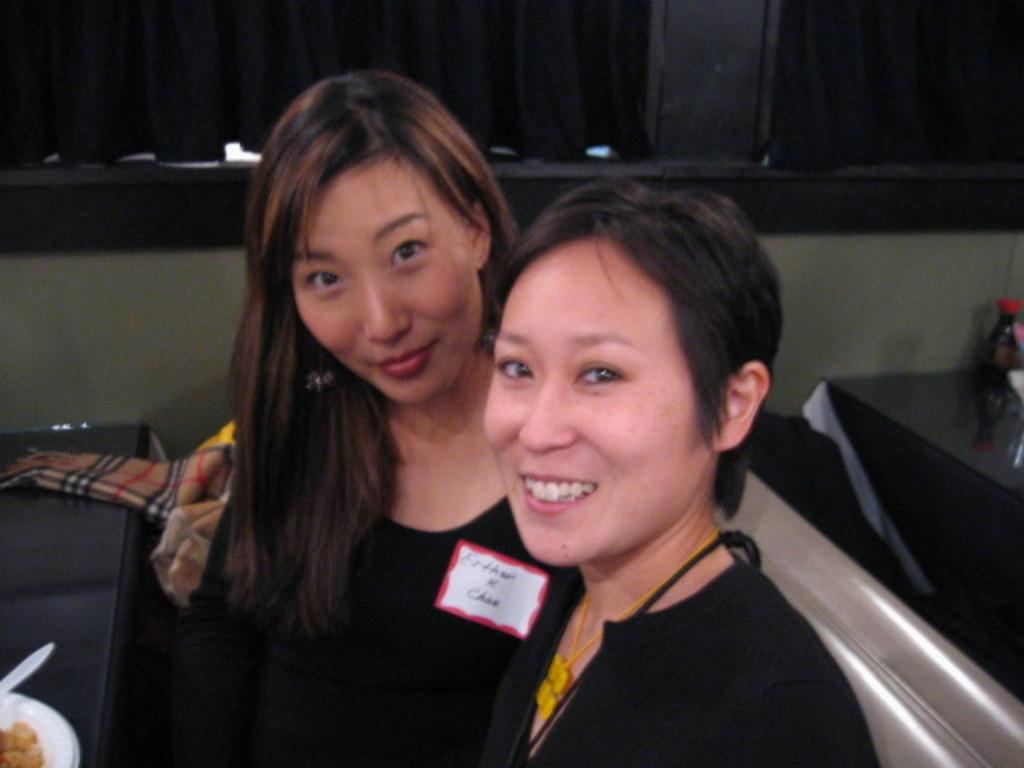How many people are in the image? There are two ladies in the image. What is present in the image besides the ladies? There is a table in the image. What is on the table in the image? There is a food item in a bowl on the table. What can be seen in the background of the image? There is a black color curtain and a wall in the background of the image. What type of clover is being discussed in the meeting in the image? There is no meeting or clover present in the image. What type of flag is visible in the image? There is no flag visible in the image. 